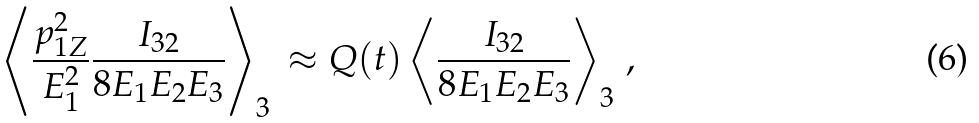Convert formula to latex. <formula><loc_0><loc_0><loc_500><loc_500>\left < \frac { p ^ { 2 } _ { 1 Z } } { E ^ { 2 } _ { 1 } } \frac { I _ { 3 2 } } { 8 E _ { 1 } E _ { 2 } E _ { 3 } } \right > _ { 3 } \, \approx Q ( t ) \left < \frac { I _ { 3 2 } } { 8 E _ { 1 } E _ { 2 } E _ { 3 } } \right > _ { 3 } \, ,</formula> 